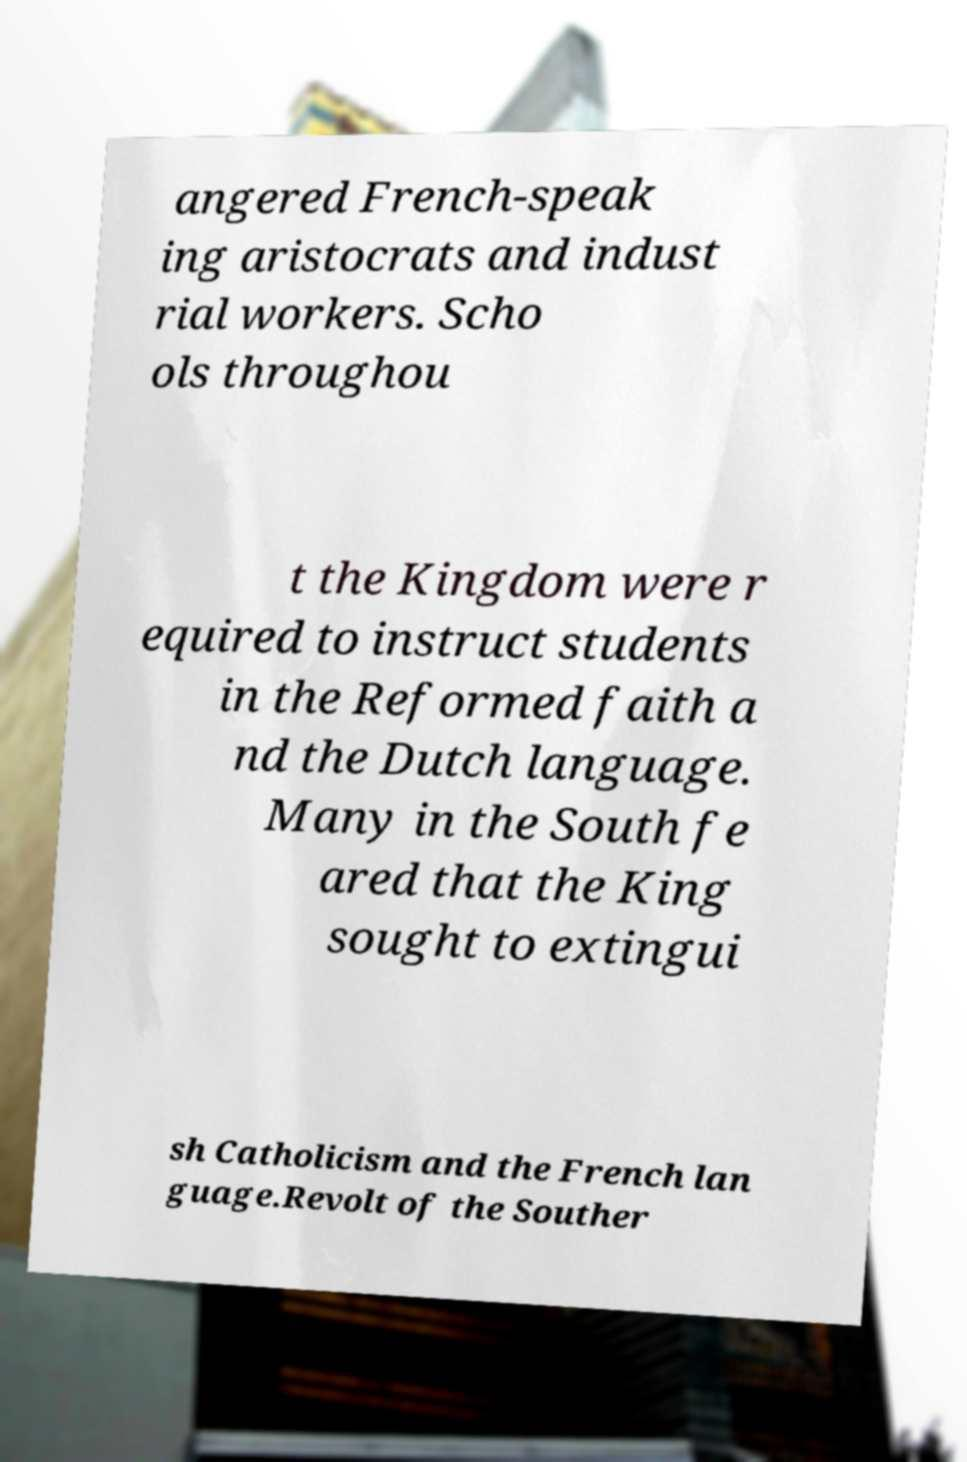There's text embedded in this image that I need extracted. Can you transcribe it verbatim? angered French-speak ing aristocrats and indust rial workers. Scho ols throughou t the Kingdom were r equired to instruct students in the Reformed faith a nd the Dutch language. Many in the South fe ared that the King sought to extingui sh Catholicism and the French lan guage.Revolt of the Souther 